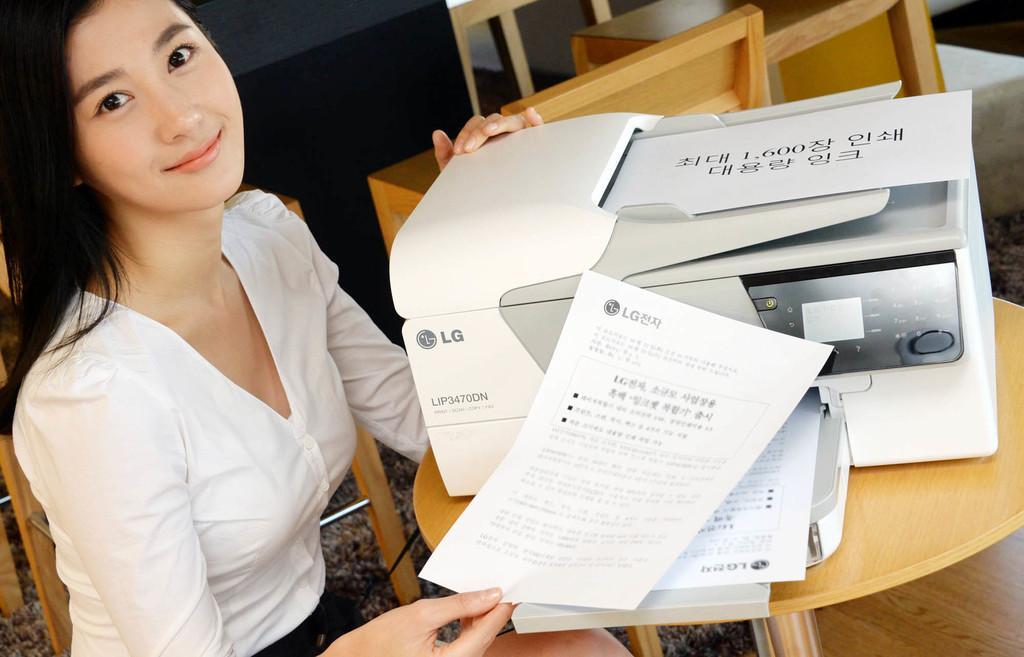In one or two sentences, can you explain what this image depicts? In this image there is a woman wearing a white top. She is holding the paper with one hand and printer with the other hand. The printer is on the table. There are chairs and tables on the floor. The woman is sitting on the chair. 